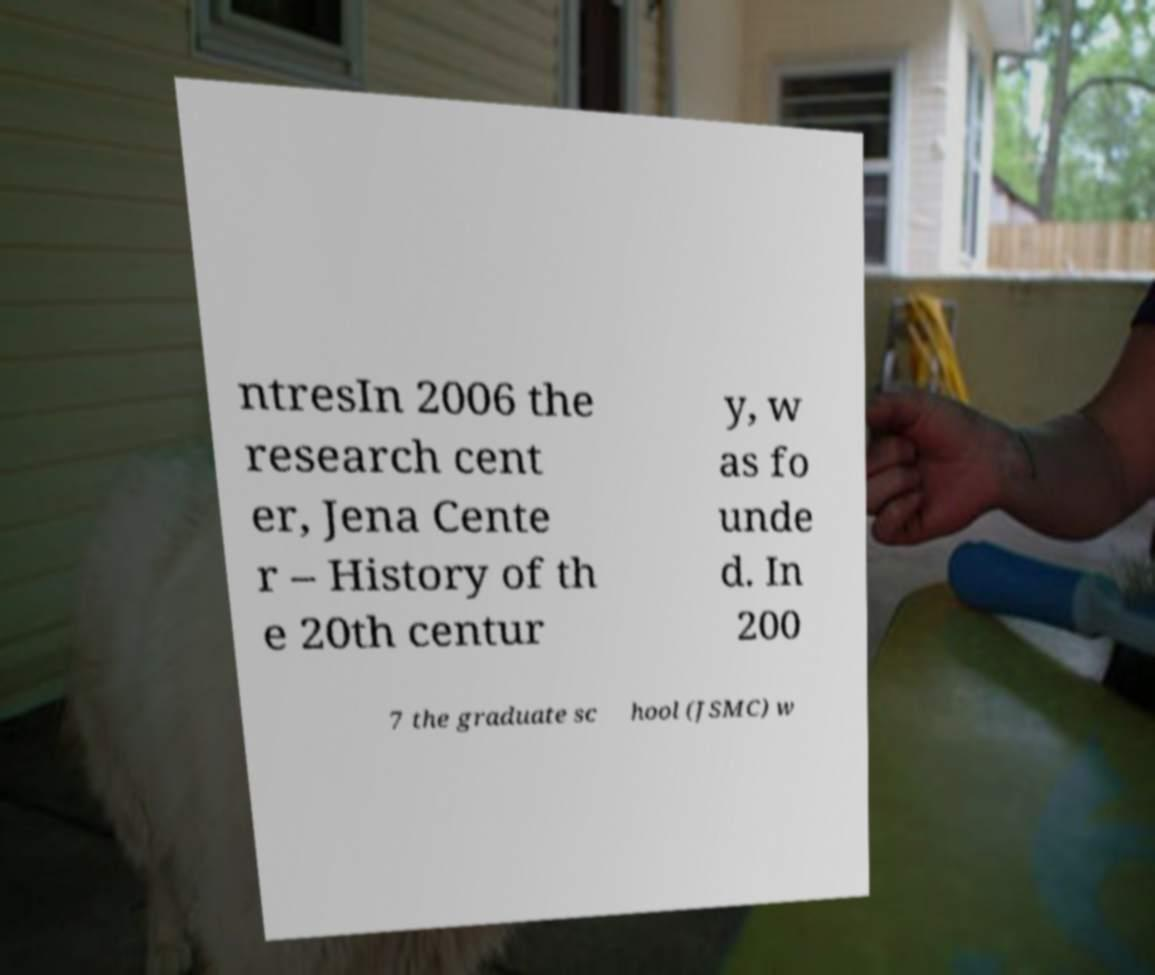Could you assist in decoding the text presented in this image and type it out clearly? ntresIn 2006 the research cent er, Jena Cente r – History of th e 20th centur y, w as fo unde d. In 200 7 the graduate sc hool (JSMC) w 